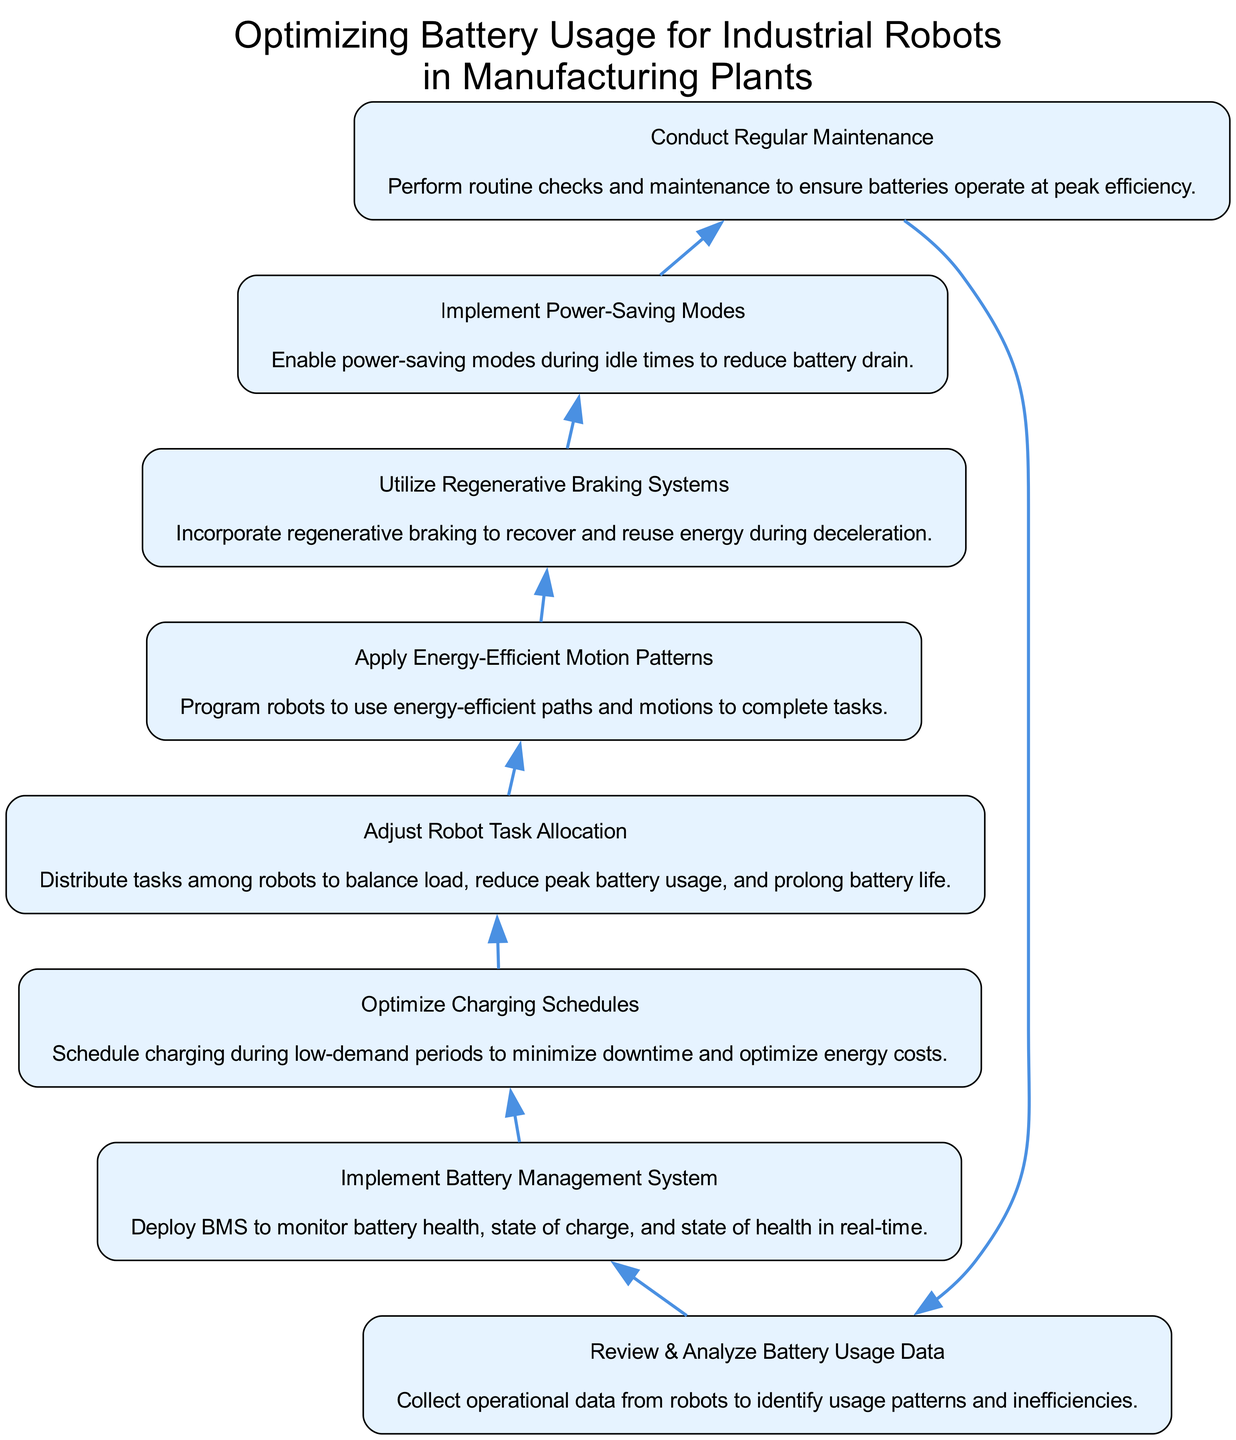What is the first step in optimizing battery usage? The first step in the diagram is "Review & Analyze Battery Usage Data." This node initiates the process and leads to the implementation of the battery management system.
Answer: Review & Analyze Battery Usage Data How many total steps are in the flow chart? To determine the total steps, we count the nodes in the diagram. There are eight distinct steps listed in the flow from bottom to top, which includes "Review & Analyze Battery Usage Data" to "Conduct Regular Maintenance."
Answer: 8 What is the last step before "Review & Analyze Battery Usage Data"? The last step before "Review & Analyze Battery Usage Data" is "Conduct Regular Maintenance." This logic follows from the directed flow of actions in the chart.
Answer: Conduct Regular Maintenance Which step involves scheduling charging? The step that involves scheduling charging is "Optimize Charging Schedules." This node is specifically focused on timing to enhance energy efficiency and minimize downtime.
Answer: Optimize Charging Schedules What does "Utilize Regenerative Braking Systems" contribute to battery usage? "Utilize Regenerative Braking Systems" enables the robots to recover and reuse energy, which is vital for extending battery life and is part of optimizing battery usage.
Answer: Recover and reuse energy What is the relationship between "Apply Energy-Efficient Motion Patterns" and "Adjust Robot Task Allocation"? "Apply Energy-Efficient Motion Patterns" follows "Adjust Robot Task Allocation" and relies on the load distribution achieved in the previous step to ensure that the energy used during task completion is optimized.
Answer: Sequential relationship What is the main focus of "Implement Power-Saving Modes"? The main focus of "Implement Power-Saving Modes" is to reduce battery drain by minimizing energy consumption during idle times, which directly aids in optimizing overall battery usage.
Answer: Reduce battery drain How many actions directly lead to "Conduct Regular Maintenance"? Only one action directly leads to "Conduct Regular Maintenance," which is "Implement Power-Saving Modes." The directed flow indicates this as the only predecessor step.
Answer: 1 What is the purpose of conducting regular maintenance? The purpose of conducting regular maintenance is to ensure that batteries operate at peak efficiency, which maximizes their lifespan and effectiveness in energy usage.
Answer: Ensure peak efficiency 